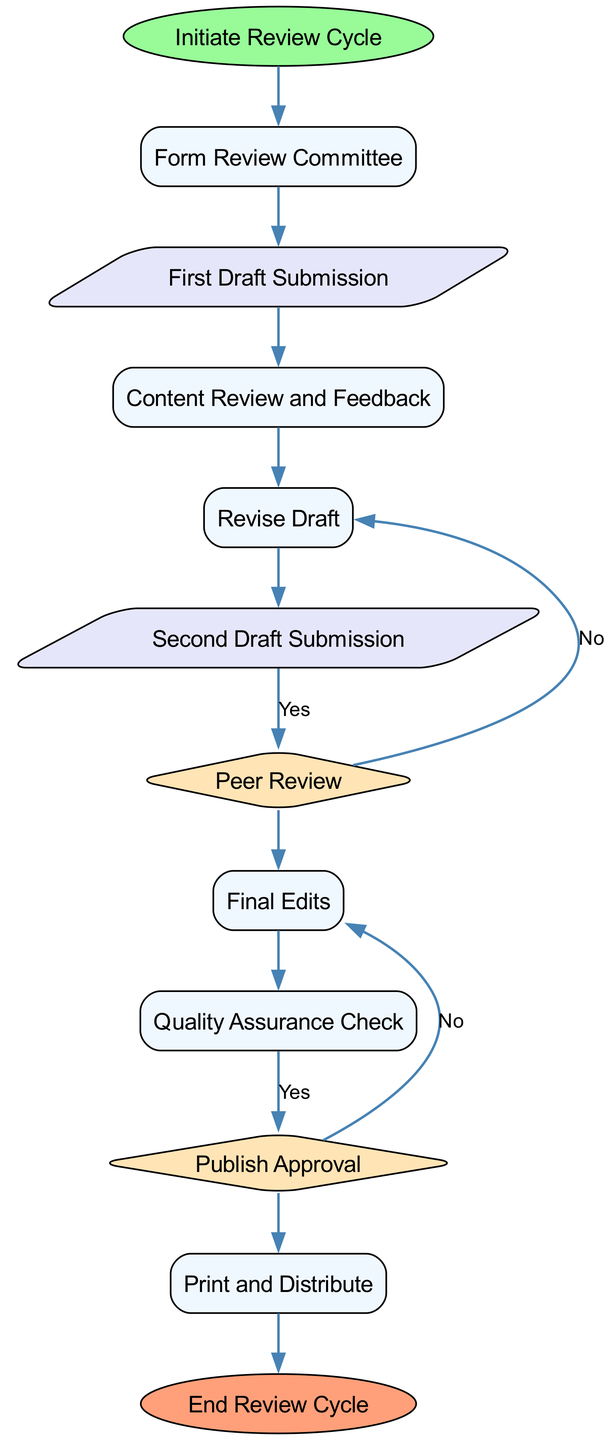What is the first step in the review cycle? The diagram indicates that the process begins with the "Initiate Review Cycle" node, which is the first step in the sequence.
Answer: Initiate Review Cycle How many processes are there in the diagram? The diagram consists of several process nodes namely, "Form Review Committee," "Content Review and Feedback," "Revise Draft," "Final Edits," and "Quality Assurance Check." Counting these, there are five processes in total.
Answer: Five What follows after the "Second Draft Submission"? After the "Second Draft Submission" node, the next step in the diagram is the "Peer Review," indicating that this is the next action to take after submitting the revised draft.
Answer: Peer Review What happens if the "Publish Approval" is rejected? According to the diagram, if the "Publish Approval" is rejected, it would logically lead back to the process requiring revisions, as indicated by the "No" edge leading off from the "Publish Approval" node.
Answer: Require further revisions What is the last step in the review cycle? The final step in the diagram is labeled "End Review Cycle," which signifies the conclusion of the entire review process once the textbook is published and distributed.
Answer: End Review Cycle What is the total number of nodes in the diagram? The total number of nodes in the diagram includes both the process nodes and decision nodes. Counting all types of nodes, there are a total of twelve distinct nodes.
Answer: Twelve How many decisions are present, and what are they? Reviewing the diagram, there are two decision nodes: "Peer Review" and "Publish Approval." This indicates key decision points where evaluations are made.
Answer: Two: Peer Review and Publish Approval What is the relationship between "Final Edits" and "Quality Assurance Check"? The flowchart illustrates that "Final Edits" is a process that comes before "Quality Assurance Check," indicating that final adjustments to the textbook should be made prior to any quality checks being performed.
Answer: Final Edits precedes Quality Assurance Check 